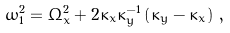Convert formula to latex. <formula><loc_0><loc_0><loc_500><loc_500>\omega _ { 1 } ^ { 2 } = \Omega _ { x } ^ { 2 } + 2 \kappa _ { x } \kappa _ { y } ^ { - 1 } \left ( \kappa _ { y } - \kappa _ { x } \right ) \, ,</formula> 